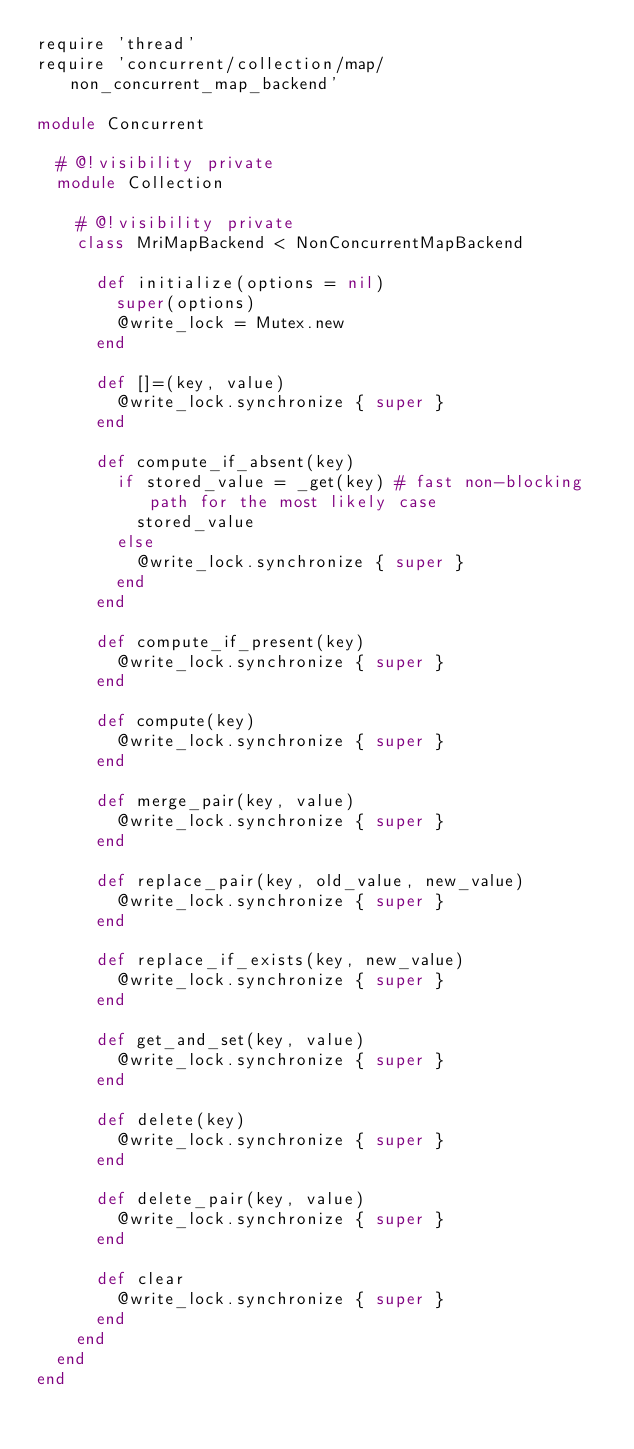<code> <loc_0><loc_0><loc_500><loc_500><_Ruby_>require 'thread'
require 'concurrent/collection/map/non_concurrent_map_backend'

module Concurrent

  # @!visibility private
  module Collection

    # @!visibility private
    class MriMapBackend < NonConcurrentMapBackend

      def initialize(options = nil)
        super(options)
        @write_lock = Mutex.new
      end

      def []=(key, value)
        @write_lock.synchronize { super }
      end

      def compute_if_absent(key)
        if stored_value = _get(key) # fast non-blocking path for the most likely case
          stored_value
        else
          @write_lock.synchronize { super }
        end
      end

      def compute_if_present(key)
        @write_lock.synchronize { super }
      end

      def compute(key)
        @write_lock.synchronize { super }
      end

      def merge_pair(key, value)
        @write_lock.synchronize { super }
      end

      def replace_pair(key, old_value, new_value)
        @write_lock.synchronize { super }
      end

      def replace_if_exists(key, new_value)
        @write_lock.synchronize { super }
      end

      def get_and_set(key, value)
        @write_lock.synchronize { super }
      end

      def delete(key)
        @write_lock.synchronize { super }
      end

      def delete_pair(key, value)
        @write_lock.synchronize { super }
      end

      def clear
        @write_lock.synchronize { super }
      end
    end
  end
end
</code> 